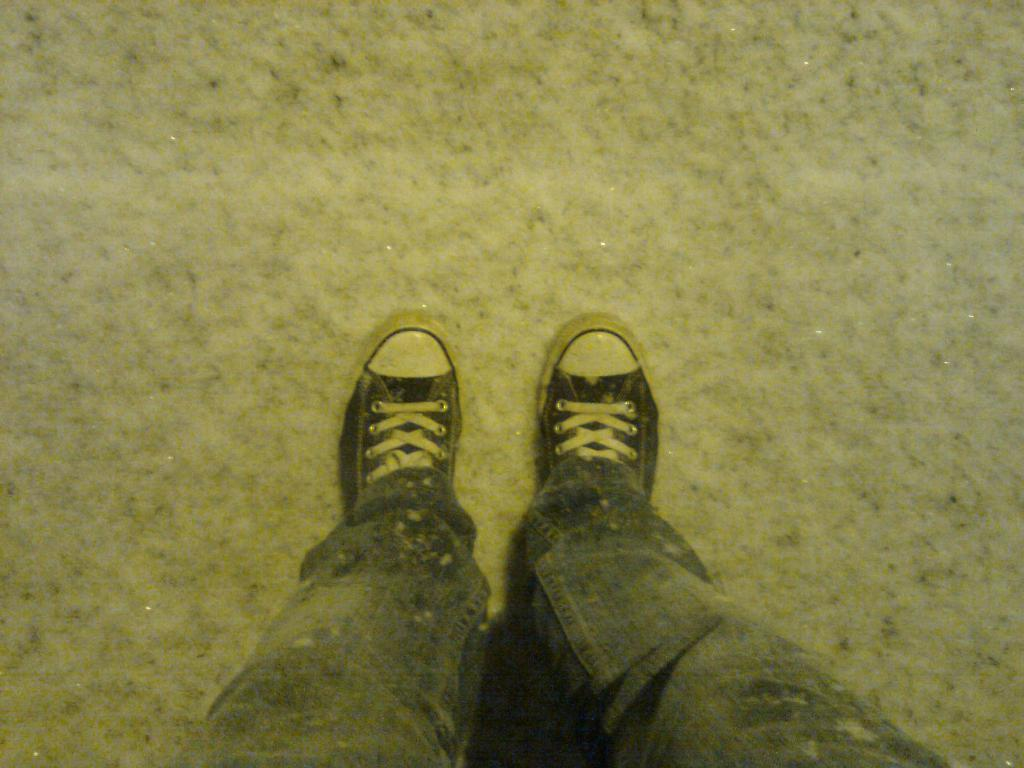What part of a person can be seen in the image? There are legs of a person in the image. What type of footwear is the person wearing? The person is wearing shoes. Can you describe the environment around the person? It appears there is ice around the person. What type of engine can be seen powering the chickens in the image? There are no chickens or engines present in the image. How does the person communicate with others in the image? The image does not show the person talking or communicating with others. 